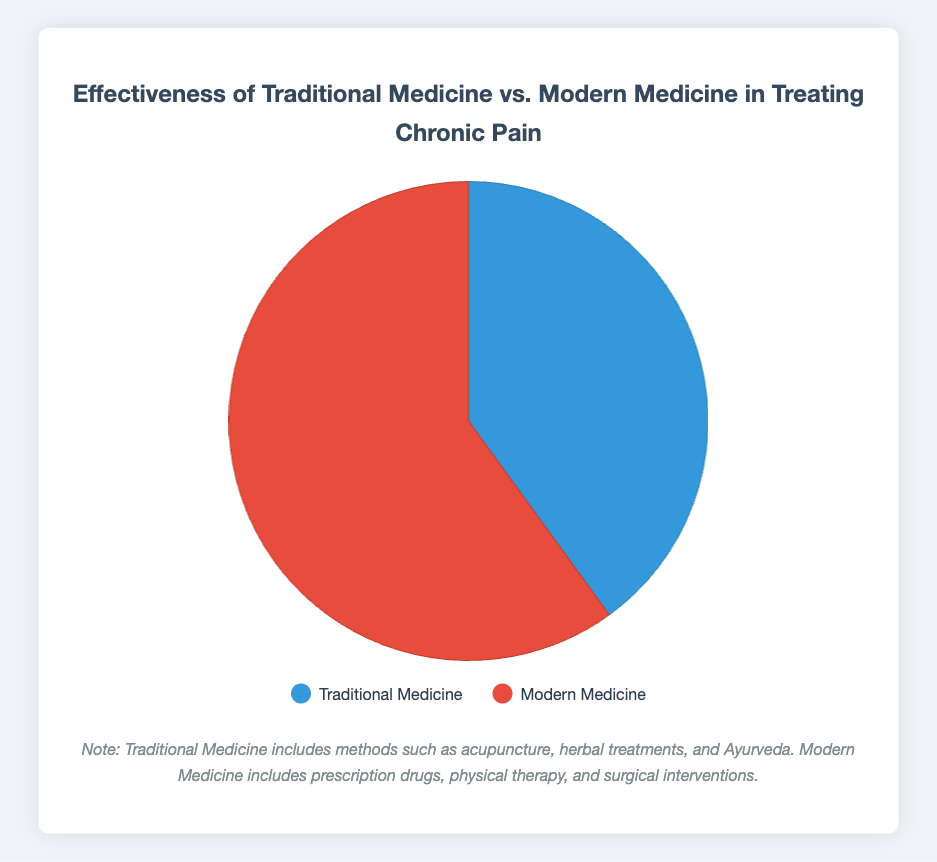Which category has the higher percentage in the Pie chart? The figure shows two categories, Traditional Medicine and Modern Medicine, with percentages 40% and 60%, respectively. Modern Medicine explicitly has the higher percentage.
Answer: Modern Medicine What is the difference in effectiveness percentage between Modern Medicine and Traditional Medicine? The figure indicates 60% for Modern Medicine and 40% for Traditional Medicine. The difference is calculated by subtracting 40% from 60%, which is 20%.
Answer: 20% If 100 patients were treated, how many would likely benefit from Traditional Medicine? The effectiveness of Traditional Medicine is given as 40%. To find the number of patients, calculate 40% of 100, which equals 40 patients.
Answer: 40 If 1000 patients were treated, how many more patients would benefit from Modern Medicine compared to Traditional Medicine? For 1000 patients, 60% would benefit from Modern Medicine and 40% from Traditional Medicine. This calculates to 600 for Modern Medicine and 400 for Traditional Medicine. Subtracting these yields 200 more patients benefiting from Modern Medicine.
Answer: 200 Considering the colors in the Pie chart, which color represents Traditional Medicine? The Pie chart uses blue for Traditional Medicine and red for Modern Medicine. The color label and legend indicate this representation.
Answer: Blue What percentage of patients treated with either method did not benefit from Traditional Medicine? Traditional Medicine is effective for 40% of patients, implying the remaining 60% did not benefit from it.
Answer: 60% What is the combined percentage of patients benefiting from either treatment method, Traditional or Modern Medicine? Traditional Medicine has 40% effectiveness and Modern Medicine 60%. Adding these two percentages gives 100% for both methods combined.
Answer: 100% Compare the visual proportion of the Pie chart between Traditional and Modern Medicine. The Pie chart visually represents Modern Medicine (60%) as larger than Traditional Medicine (40%), reflecting the data percentages accurately.
Answer: Modern Medicine has a larger proportion How much larger is the red section compared to the blue section in the Pie chart? The red section represents 60% (Modern Medicine) and the blue section represents 40% (Traditional Medicine). The difference or how much larger, calculated by subtracting 40% from 60%, results in 20%.
Answer: 20% If the Pie chart were divided into 10 equal segments, how many segments would represent Modern Medicine? Each segment of the Pie chart represents 10% (since 100% divided by 10 equals 10%). Modern Medicine, being 60%, would thus span 6 segments.
Answer: 6 